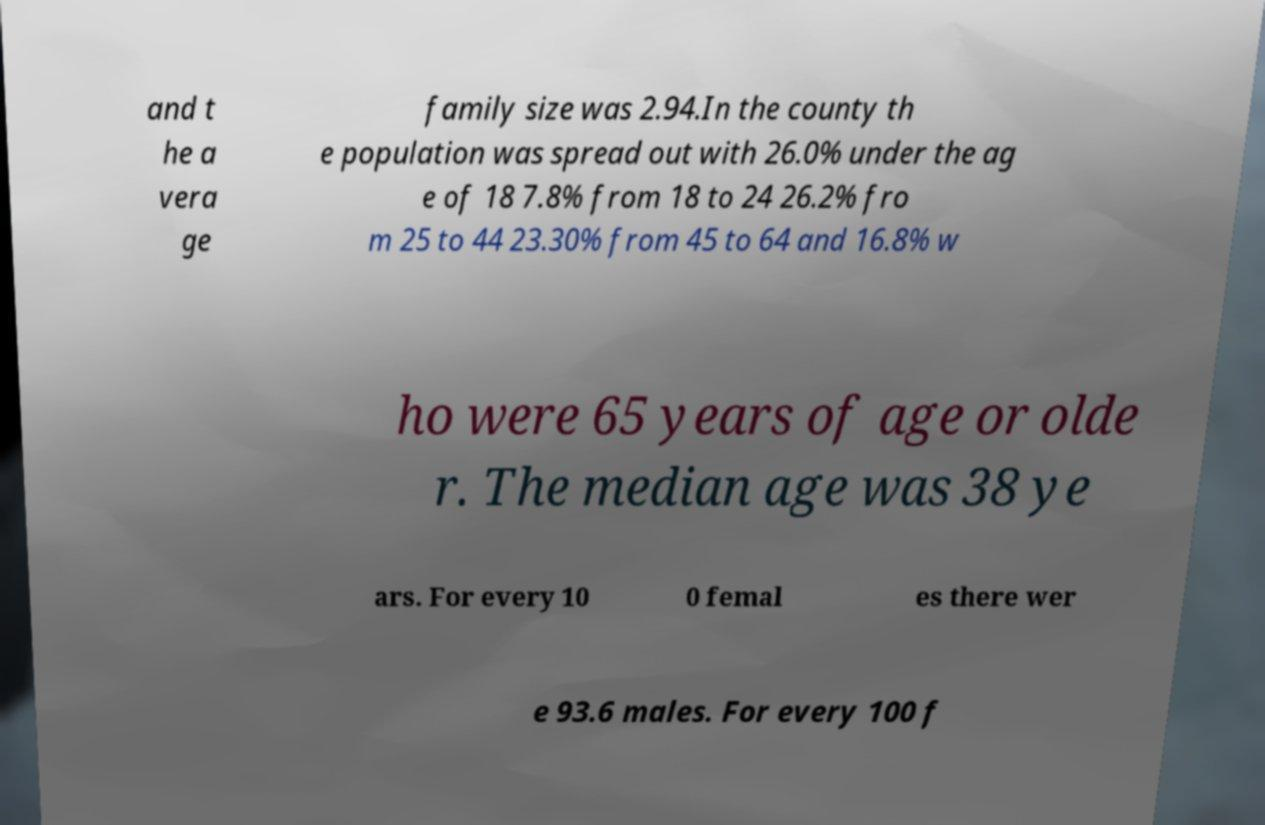Please identify and transcribe the text found in this image. and t he a vera ge family size was 2.94.In the county th e population was spread out with 26.0% under the ag e of 18 7.8% from 18 to 24 26.2% fro m 25 to 44 23.30% from 45 to 64 and 16.8% w ho were 65 years of age or olde r. The median age was 38 ye ars. For every 10 0 femal es there wer e 93.6 males. For every 100 f 